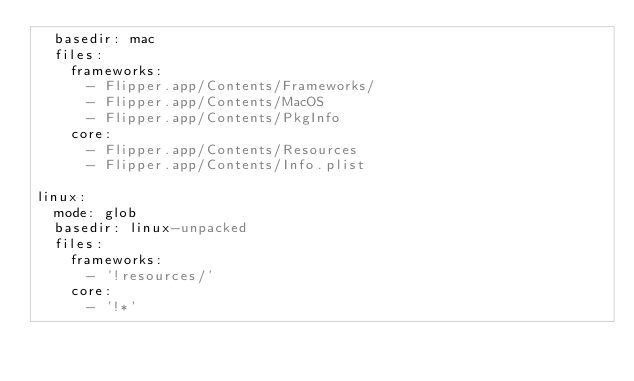Convert code to text. <code><loc_0><loc_0><loc_500><loc_500><_YAML_>  basedir: mac
  files:
    frameworks:
      - Flipper.app/Contents/Frameworks/
      - Flipper.app/Contents/MacOS
      - Flipper.app/Contents/PkgInfo
    core:
      - Flipper.app/Contents/Resources
      - Flipper.app/Contents/Info.plist

linux:
  mode: glob
  basedir: linux-unpacked
  files:
    frameworks:
      - '!resources/'
    core:
      - '!*'</code> 